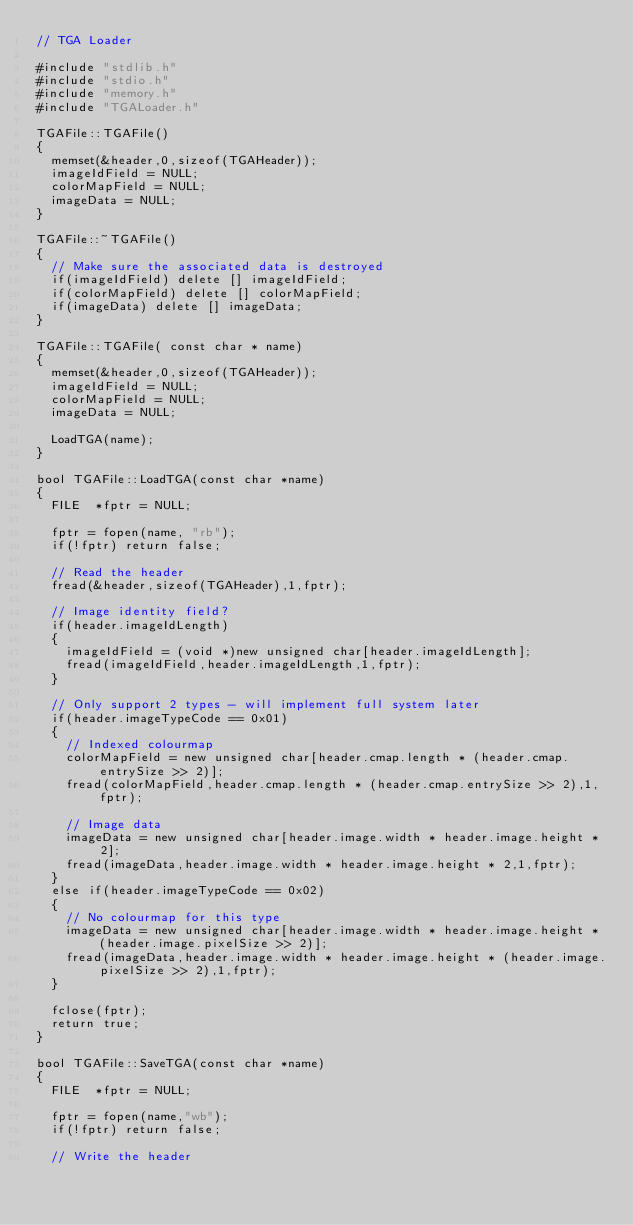<code> <loc_0><loc_0><loc_500><loc_500><_C++_>// TGA Loader

#include "stdlib.h"
#include "stdio.h"
#include "memory.h"
#include "TGALoader.h"

TGAFile::TGAFile()
{
	memset(&header,0,sizeof(TGAHeader));
	imageIdField = NULL;
	colorMapField = NULL;
	imageData = NULL;
}

TGAFile::~TGAFile()
{
	// Make sure the associated data is destroyed
	if(imageIdField) delete [] imageIdField;
	if(colorMapField) delete [] colorMapField;
	if(imageData) delete [] imageData;
}

TGAFile::TGAFile( const char * name)
{ 
	memset(&header,0,sizeof(TGAHeader));
	imageIdField = NULL;
	colorMapField = NULL;
	imageData = NULL;

	LoadTGA(name); 
}

bool TGAFile::LoadTGA(const char *name)
{
	FILE	*fptr = NULL;

	fptr = fopen(name, "rb");
	if(!fptr) return false;

	// Read the header
	fread(&header,sizeof(TGAHeader),1,fptr);

	// Image identity field?
	if(header.imageIdLength)
	{
		imageIdField = (void *)new unsigned char[header.imageIdLength];
		fread(imageIdField,header.imageIdLength,1,fptr);
	}

	// Only support 2 types - will implement full system later
	if(header.imageTypeCode == 0x01)
	{
		// Indexed colourmap 
		colorMapField = new unsigned char[header.cmap.length * (header.cmap.entrySize >> 2)];
		fread(colorMapField,header.cmap.length * (header.cmap.entrySize >> 2),1,fptr);

		// Image data
		imageData = new unsigned char[header.image.width * header.image.height * 2];
		fread(imageData,header.image.width * header.image.height * 2,1,fptr);
	}
	else if(header.imageTypeCode == 0x02)
	{
		// No colourmap for this type
		imageData = new unsigned char[header.image.width * header.image.height * (header.image.pixelSize >> 2)];
		fread(imageData,header.image.width * header.image.height * (header.image.pixelSize >> 2),1,fptr);
	}

	fclose(fptr);
	return true;
}

bool TGAFile::SaveTGA(const char *name)
{
	FILE	*fptr = NULL;

	fptr = fopen(name,"wb");
	if(!fptr) return false;

	// Write the header</code> 